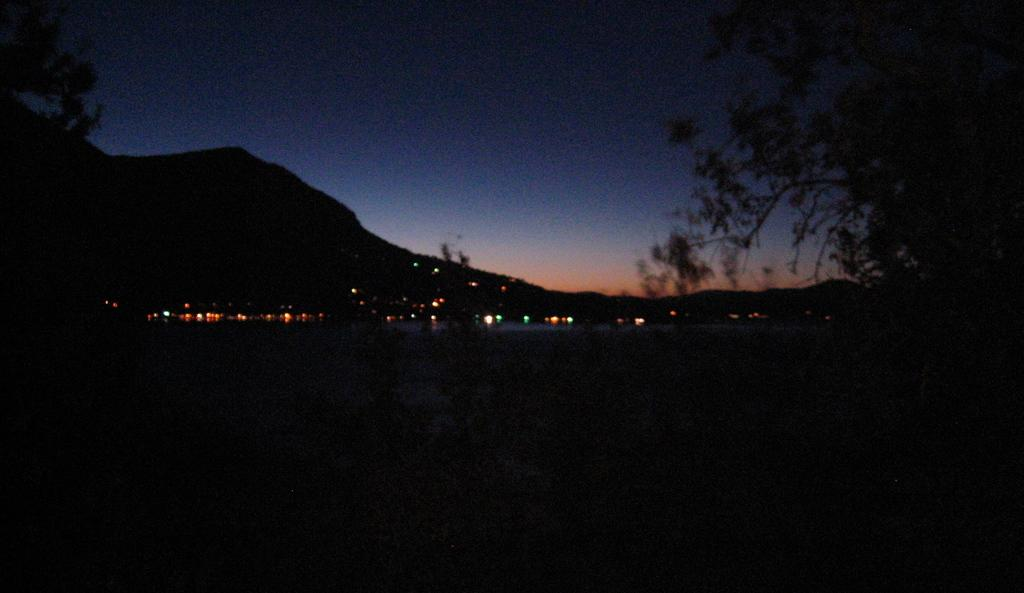What can be seen in the background of the image? There are lights in the background of the image. What is located on the right side of the image? There is a tree on the right side of the image. What type of vegetation is on the left side of the image? There are leaves on the left side of the image. What type of whip is being used by the mother in the image? There is no mother or whip present in the image. What observation can be made about the interaction between the lights and the tree in the image? There is no interaction between the lights and the tree mentioned in the provided facts, so it is not possible to make such an observation. 